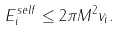<formula> <loc_0><loc_0><loc_500><loc_500>E _ { i } ^ { s e l f } \leq 2 \pi M ^ { 2 } v _ { i } .</formula> 